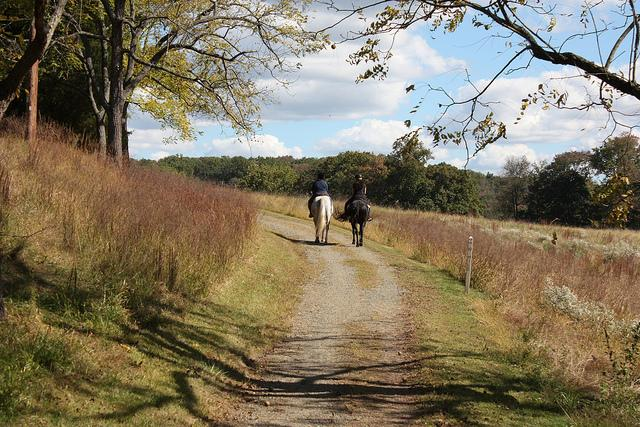What animals are present? Please explain your reasoning. horse. Two horses are a little ways up the dirt road, and both are being ridden today by their respective owners. 